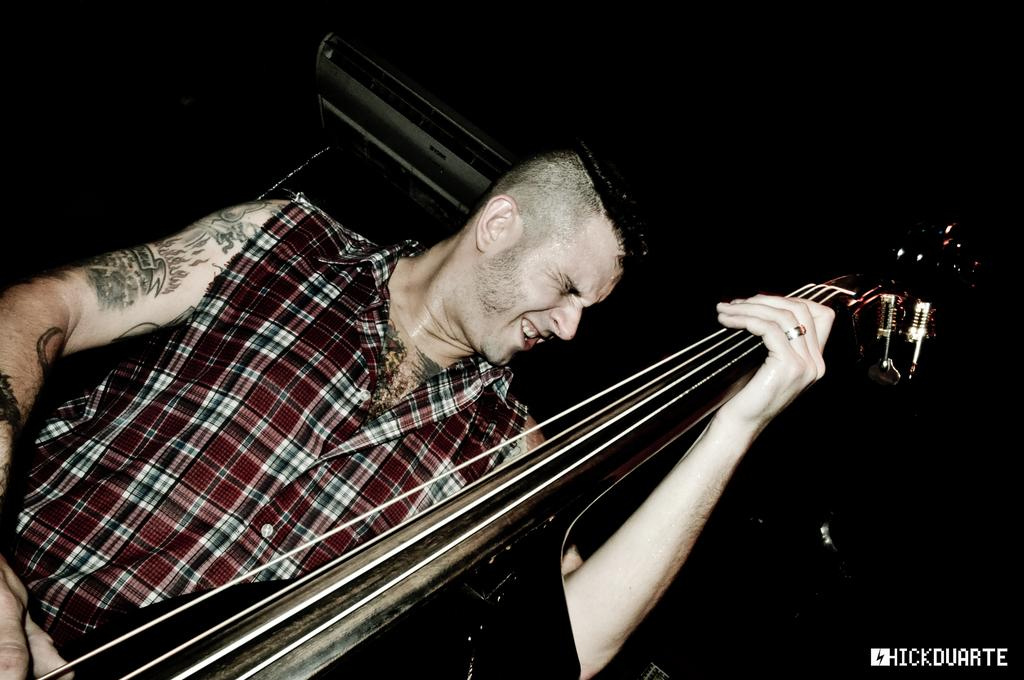What can be seen in the image? There is a person in the image. Can you describe the person's attire? The person is wearing a dress. What is the person holding in the image? The person is holding a musical instrument. What is the color of the background in the image? The background of the image is black. Are there any visible signs of expansion or cobwebs in the image? No, there are no visible signs of expansion or cobwebs in the image. Is there any indication of a pest problem in the image? No, there is no indication of a pest problem in the image. 